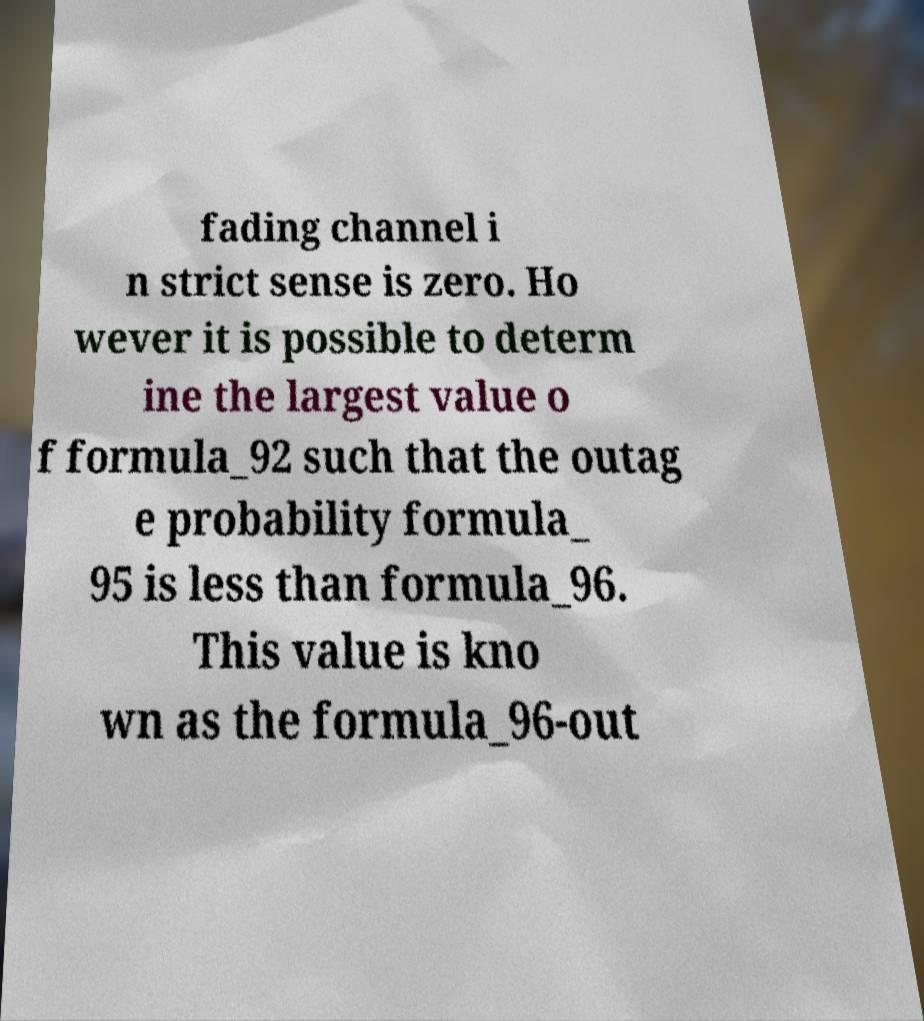Please read and relay the text visible in this image. What does it say? fading channel i n strict sense is zero. Ho wever it is possible to determ ine the largest value o f formula_92 such that the outag e probability formula_ 95 is less than formula_96. This value is kno wn as the formula_96-out 